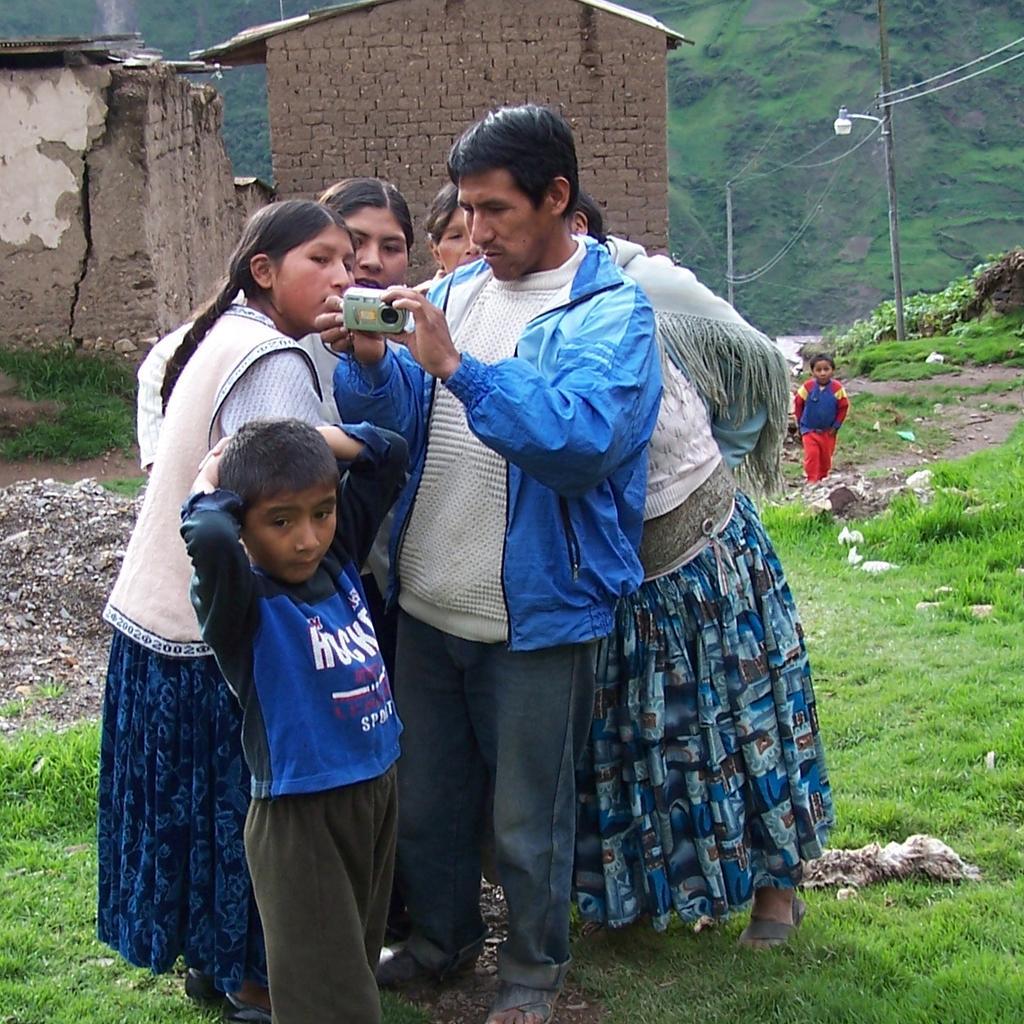In one or two sentences, can you explain what this image depicts? In this image we can see there are people standing on the ground and one person holding a camera. At the back there are houses. And there are light poles, grass, stones and mountain. 